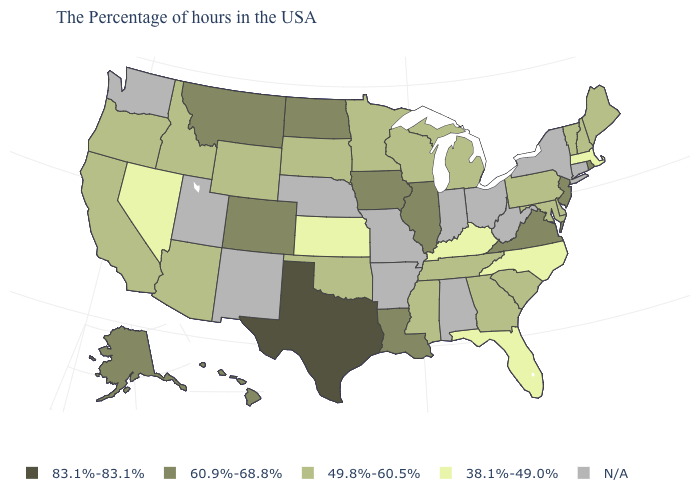Does the first symbol in the legend represent the smallest category?
Answer briefly. No. What is the value of Ohio?
Short answer required. N/A. What is the value of Oklahoma?
Short answer required. 49.8%-60.5%. What is the value of New Jersey?
Keep it brief. 60.9%-68.8%. What is the value of Kansas?
Short answer required. 38.1%-49.0%. What is the lowest value in states that border Kansas?
Be succinct. 49.8%-60.5%. Name the states that have a value in the range 83.1%-83.1%?
Quick response, please. Texas. Does the first symbol in the legend represent the smallest category?
Quick response, please. No. What is the value of Alaska?
Concise answer only. 60.9%-68.8%. What is the highest value in the West ?
Answer briefly. 60.9%-68.8%. Does Kansas have the lowest value in the MidWest?
Be succinct. Yes. Which states have the lowest value in the USA?
Give a very brief answer. Massachusetts, North Carolina, Florida, Kentucky, Kansas, Nevada. Does Texas have the highest value in the USA?
Give a very brief answer. Yes. 